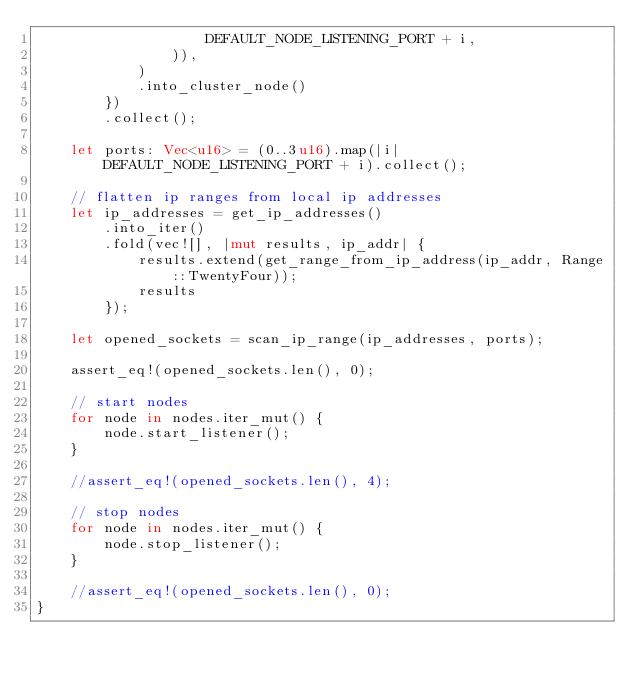<code> <loc_0><loc_0><loc_500><loc_500><_Rust_>                    DEFAULT_NODE_LISTENING_PORT + i,
                )),
            )
            .into_cluster_node()
        })
        .collect();

    let ports: Vec<u16> = (0..3u16).map(|i| DEFAULT_NODE_LISTENING_PORT + i).collect();

    // flatten ip ranges from local ip addresses
    let ip_addresses = get_ip_addresses()
        .into_iter()
        .fold(vec![], |mut results, ip_addr| {
            results.extend(get_range_from_ip_address(ip_addr, Range::TwentyFour));
            results
        });

    let opened_sockets = scan_ip_range(ip_addresses, ports);

    assert_eq!(opened_sockets.len(), 0);

    // start nodes
    for node in nodes.iter_mut() {
        node.start_listener();
    }

    //assert_eq!(opened_sockets.len(), 4);

    // stop nodes
    for node in nodes.iter_mut() {
        node.stop_listener();
    }

    //assert_eq!(opened_sockets.len(), 0);
}
</code> 